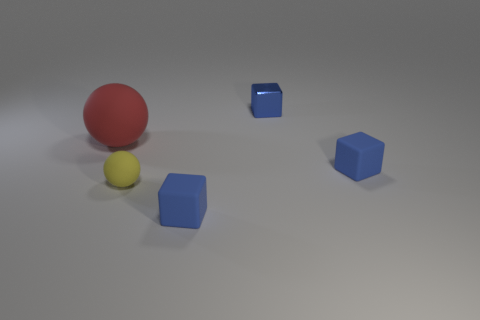Is there a large green object that has the same material as the red ball?
Keep it short and to the point. No. Is the shape of the thing that is in front of the small yellow rubber ball the same as  the small shiny thing?
Your response must be concise. Yes. How many cubes are to the right of the blue matte cube that is to the left of the blue matte object right of the blue metallic block?
Provide a short and direct response. 2. Are there fewer big red rubber spheres that are in front of the big object than small blue blocks in front of the small rubber ball?
Ensure brevity in your answer.  Yes. There is another matte thing that is the same shape as the tiny yellow matte object; what is its color?
Keep it short and to the point. Red. The metallic cube is what size?
Keep it short and to the point. Small. How many blue matte blocks have the same size as the yellow rubber sphere?
Ensure brevity in your answer.  2. Is the color of the small sphere the same as the large object?
Offer a very short reply. No. Are the small blue block that is on the left side of the shiny cube and the ball that is to the left of the small rubber ball made of the same material?
Offer a very short reply. Yes. Is the number of small metal cubes greater than the number of blue rubber objects?
Your response must be concise. No. 